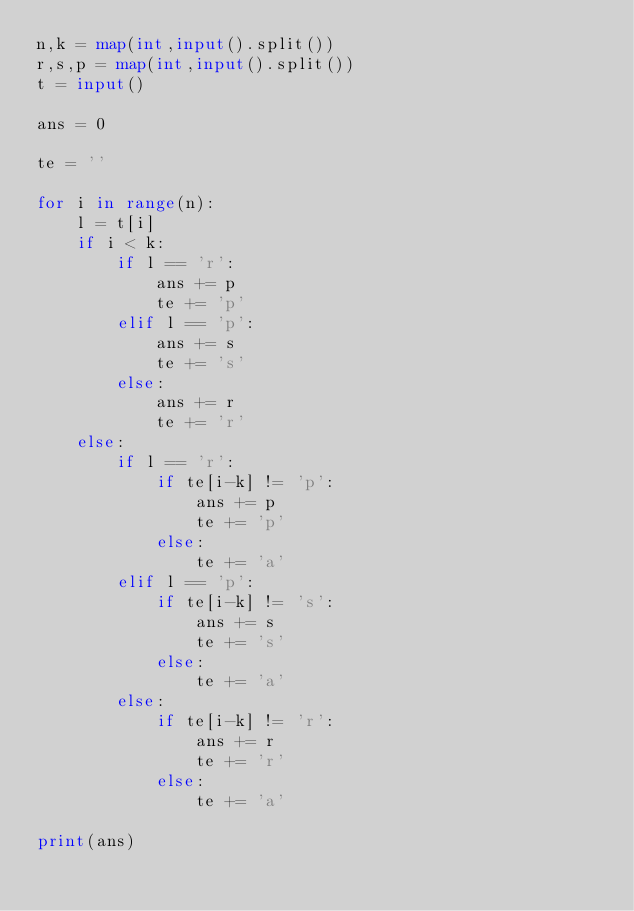<code> <loc_0><loc_0><loc_500><loc_500><_Python_>n,k = map(int,input().split())
r,s,p = map(int,input().split())
t = input()

ans = 0

te = ''

for i in range(n):
    l = t[i]
    if i < k:
        if l == 'r':
            ans += p
            te += 'p'
        elif l == 'p':
            ans += s
            te += 's'
        else:
            ans += r
            te += 'r'
    else:
        if l == 'r':
            if te[i-k] != 'p':
                ans += p
                te += 'p'
            else:
                te += 'a'
        elif l == 'p':
            if te[i-k] != 's':
                ans += s
                te += 's'
            else:
                te += 'a'
        else:
            if te[i-k] != 'r':
                ans += r
                te += 'r'
            else:
                te += 'a'

print(ans)
</code> 